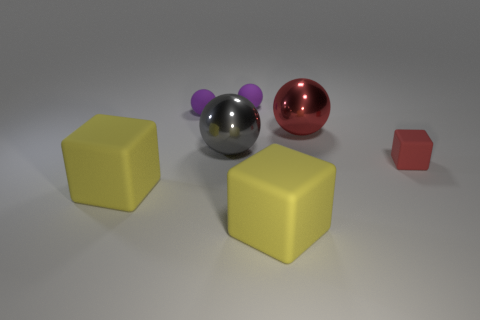How many matte things are either cubes or tiny cubes?
Offer a very short reply. 3. What is the material of the small ball behind the small purple rubber ball that is in front of the small purple thing that is on the right side of the large gray object?
Make the answer very short. Rubber. There is a red thing to the right of the red thing behind the tiny matte block; what is it made of?
Your answer should be very brief. Rubber. Does the purple ball right of the big gray metallic sphere have the same size as the red thing that is on the left side of the red rubber thing?
Provide a succinct answer. No. Are there any other things that have the same material as the tiny red block?
Your response must be concise. Yes. What number of tiny things are gray shiny objects or yellow matte cubes?
Your response must be concise. 0. What number of objects are either objects that are in front of the red rubber object or green blocks?
Keep it short and to the point. 2. How many other things are there of the same shape as the small red matte thing?
Ensure brevity in your answer.  2. How many purple objects are small balls or small objects?
Provide a succinct answer. 2. What is the color of the large thing that is the same material as the red ball?
Offer a terse response. Gray. 